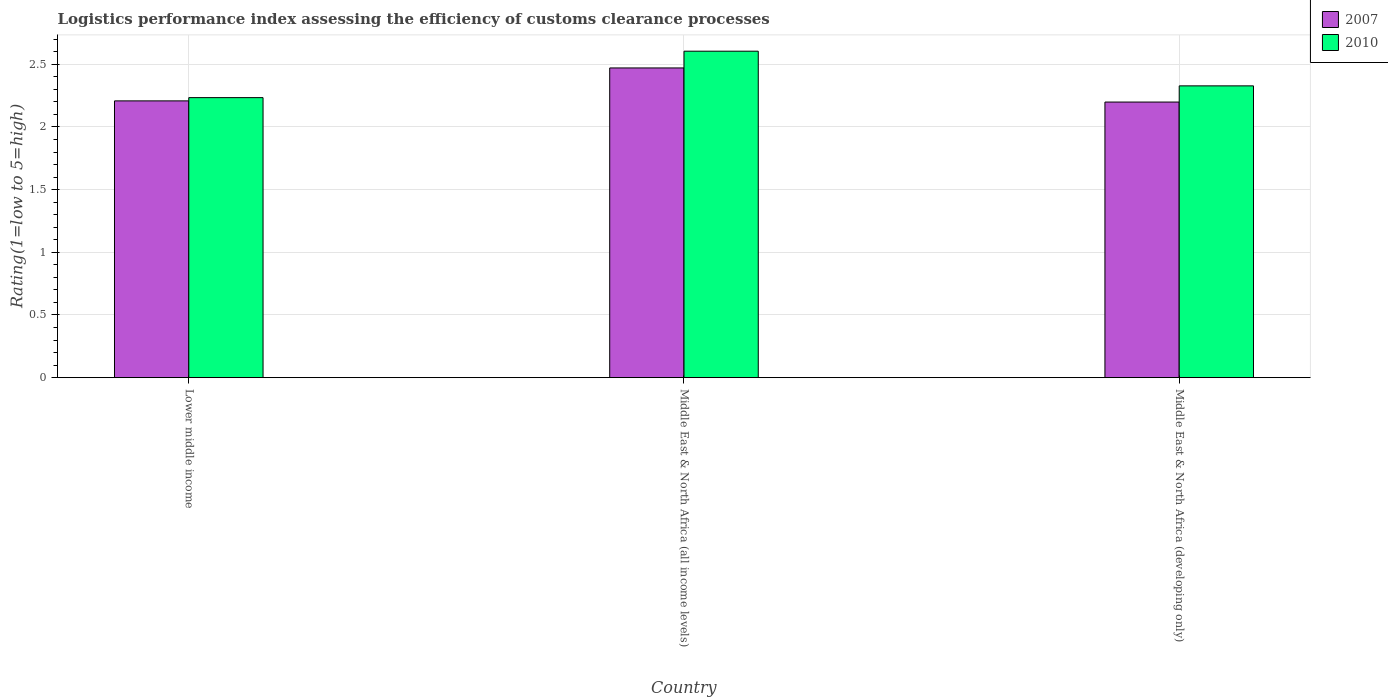What is the label of the 3rd group of bars from the left?
Your response must be concise. Middle East & North Africa (developing only). In how many cases, is the number of bars for a given country not equal to the number of legend labels?
Offer a terse response. 0. What is the Logistic performance index in 2010 in Middle East & North Africa (developing only)?
Ensure brevity in your answer.  2.33. Across all countries, what is the maximum Logistic performance index in 2007?
Give a very brief answer. 2.47. Across all countries, what is the minimum Logistic performance index in 2010?
Ensure brevity in your answer.  2.23. In which country was the Logistic performance index in 2010 maximum?
Provide a short and direct response. Middle East & North Africa (all income levels). In which country was the Logistic performance index in 2007 minimum?
Make the answer very short. Middle East & North Africa (developing only). What is the total Logistic performance index in 2007 in the graph?
Your response must be concise. 6.88. What is the difference between the Logistic performance index in 2010 in Middle East & North Africa (all income levels) and that in Middle East & North Africa (developing only)?
Your answer should be very brief. 0.28. What is the difference between the Logistic performance index in 2010 in Lower middle income and the Logistic performance index in 2007 in Middle East & North Africa (all income levels)?
Offer a terse response. -0.24. What is the average Logistic performance index in 2010 per country?
Provide a short and direct response. 2.39. What is the difference between the Logistic performance index of/in 2007 and Logistic performance index of/in 2010 in Middle East & North Africa (all income levels)?
Your answer should be compact. -0.13. In how many countries, is the Logistic performance index in 2007 greater than 1.3?
Ensure brevity in your answer.  3. What is the ratio of the Logistic performance index in 2010 in Middle East & North Africa (all income levels) to that in Middle East & North Africa (developing only)?
Ensure brevity in your answer.  1.12. Is the Logistic performance index in 2010 in Lower middle income less than that in Middle East & North Africa (developing only)?
Provide a short and direct response. Yes. Is the difference between the Logistic performance index in 2007 in Middle East & North Africa (all income levels) and Middle East & North Africa (developing only) greater than the difference between the Logistic performance index in 2010 in Middle East & North Africa (all income levels) and Middle East & North Africa (developing only)?
Give a very brief answer. No. What is the difference between the highest and the second highest Logistic performance index in 2010?
Provide a short and direct response. 0.28. What is the difference between the highest and the lowest Logistic performance index in 2007?
Provide a short and direct response. 0.27. What does the 1st bar from the left in Middle East & North Africa (all income levels) represents?
Ensure brevity in your answer.  2007. Does the graph contain grids?
Ensure brevity in your answer.  Yes. Where does the legend appear in the graph?
Provide a succinct answer. Top right. What is the title of the graph?
Ensure brevity in your answer.  Logistics performance index assessing the efficiency of customs clearance processes. What is the label or title of the Y-axis?
Offer a terse response. Rating(1=low to 5=high). What is the Rating(1=low to 5=high) in 2007 in Lower middle income?
Ensure brevity in your answer.  2.21. What is the Rating(1=low to 5=high) in 2010 in Lower middle income?
Your response must be concise. 2.23. What is the Rating(1=low to 5=high) in 2007 in Middle East & North Africa (all income levels)?
Keep it short and to the point. 2.47. What is the Rating(1=low to 5=high) in 2010 in Middle East & North Africa (all income levels)?
Your answer should be compact. 2.6. What is the Rating(1=low to 5=high) in 2007 in Middle East & North Africa (developing only)?
Your response must be concise. 2.2. What is the Rating(1=low to 5=high) in 2010 in Middle East & North Africa (developing only)?
Provide a short and direct response. 2.33. Across all countries, what is the maximum Rating(1=low to 5=high) in 2007?
Your response must be concise. 2.47. Across all countries, what is the maximum Rating(1=low to 5=high) of 2010?
Your answer should be very brief. 2.6. Across all countries, what is the minimum Rating(1=low to 5=high) of 2007?
Keep it short and to the point. 2.2. Across all countries, what is the minimum Rating(1=low to 5=high) of 2010?
Make the answer very short. 2.23. What is the total Rating(1=low to 5=high) in 2007 in the graph?
Provide a succinct answer. 6.88. What is the total Rating(1=low to 5=high) of 2010 in the graph?
Make the answer very short. 7.17. What is the difference between the Rating(1=low to 5=high) in 2007 in Lower middle income and that in Middle East & North Africa (all income levels)?
Offer a terse response. -0.26. What is the difference between the Rating(1=low to 5=high) in 2010 in Lower middle income and that in Middle East & North Africa (all income levels)?
Keep it short and to the point. -0.37. What is the difference between the Rating(1=low to 5=high) in 2007 in Lower middle income and that in Middle East & North Africa (developing only)?
Offer a very short reply. 0.01. What is the difference between the Rating(1=low to 5=high) in 2010 in Lower middle income and that in Middle East & North Africa (developing only)?
Provide a short and direct response. -0.09. What is the difference between the Rating(1=low to 5=high) of 2007 in Middle East & North Africa (all income levels) and that in Middle East & North Africa (developing only)?
Make the answer very short. 0.27. What is the difference between the Rating(1=low to 5=high) of 2010 in Middle East & North Africa (all income levels) and that in Middle East & North Africa (developing only)?
Make the answer very short. 0.28. What is the difference between the Rating(1=low to 5=high) of 2007 in Lower middle income and the Rating(1=low to 5=high) of 2010 in Middle East & North Africa (all income levels)?
Ensure brevity in your answer.  -0.4. What is the difference between the Rating(1=low to 5=high) in 2007 in Lower middle income and the Rating(1=low to 5=high) in 2010 in Middle East & North Africa (developing only)?
Give a very brief answer. -0.12. What is the difference between the Rating(1=low to 5=high) in 2007 in Middle East & North Africa (all income levels) and the Rating(1=low to 5=high) in 2010 in Middle East & North Africa (developing only)?
Keep it short and to the point. 0.14. What is the average Rating(1=low to 5=high) of 2007 per country?
Your answer should be compact. 2.29. What is the average Rating(1=low to 5=high) in 2010 per country?
Keep it short and to the point. 2.39. What is the difference between the Rating(1=low to 5=high) in 2007 and Rating(1=low to 5=high) in 2010 in Lower middle income?
Your answer should be compact. -0.03. What is the difference between the Rating(1=low to 5=high) in 2007 and Rating(1=low to 5=high) in 2010 in Middle East & North Africa (all income levels)?
Ensure brevity in your answer.  -0.13. What is the difference between the Rating(1=low to 5=high) of 2007 and Rating(1=low to 5=high) of 2010 in Middle East & North Africa (developing only)?
Keep it short and to the point. -0.13. What is the ratio of the Rating(1=low to 5=high) of 2007 in Lower middle income to that in Middle East & North Africa (all income levels)?
Offer a very short reply. 0.89. What is the ratio of the Rating(1=low to 5=high) in 2010 in Lower middle income to that in Middle East & North Africa (all income levels)?
Offer a terse response. 0.86. What is the ratio of the Rating(1=low to 5=high) in 2007 in Lower middle income to that in Middle East & North Africa (developing only)?
Provide a succinct answer. 1. What is the ratio of the Rating(1=low to 5=high) in 2010 in Lower middle income to that in Middle East & North Africa (developing only)?
Make the answer very short. 0.96. What is the ratio of the Rating(1=low to 5=high) in 2007 in Middle East & North Africa (all income levels) to that in Middle East & North Africa (developing only)?
Your response must be concise. 1.12. What is the ratio of the Rating(1=low to 5=high) of 2010 in Middle East & North Africa (all income levels) to that in Middle East & North Africa (developing only)?
Provide a succinct answer. 1.12. What is the difference between the highest and the second highest Rating(1=low to 5=high) of 2007?
Offer a terse response. 0.26. What is the difference between the highest and the second highest Rating(1=low to 5=high) in 2010?
Your answer should be compact. 0.28. What is the difference between the highest and the lowest Rating(1=low to 5=high) in 2007?
Offer a terse response. 0.27. What is the difference between the highest and the lowest Rating(1=low to 5=high) in 2010?
Make the answer very short. 0.37. 